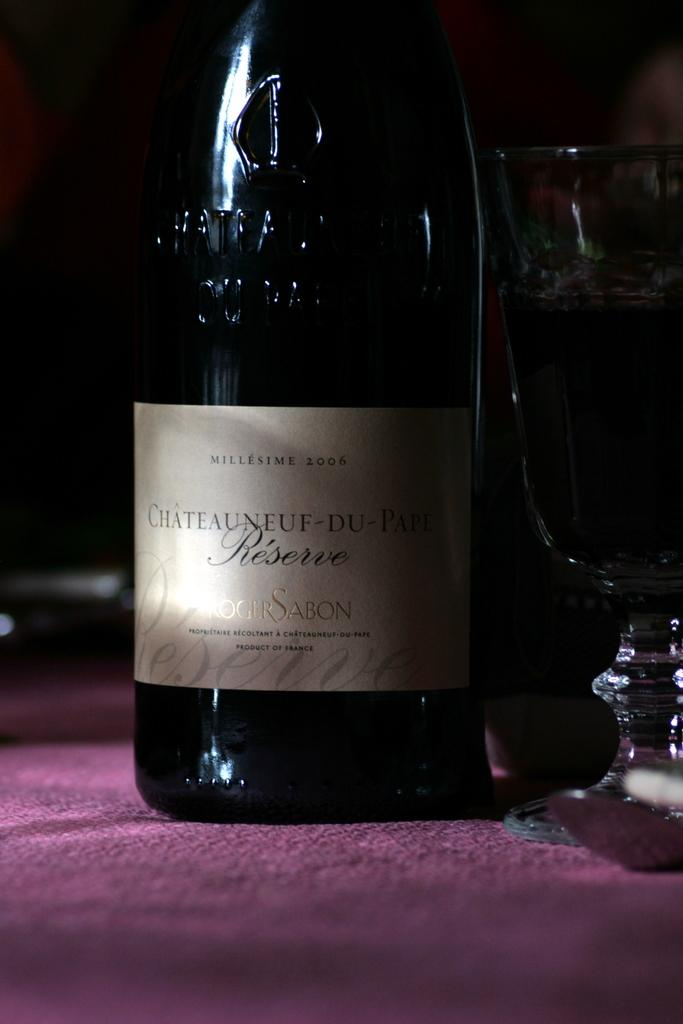<image>
Write a terse but informative summary of the picture. A large bottle of Millesime 2006 Chateauneuf-Du Reserve. 